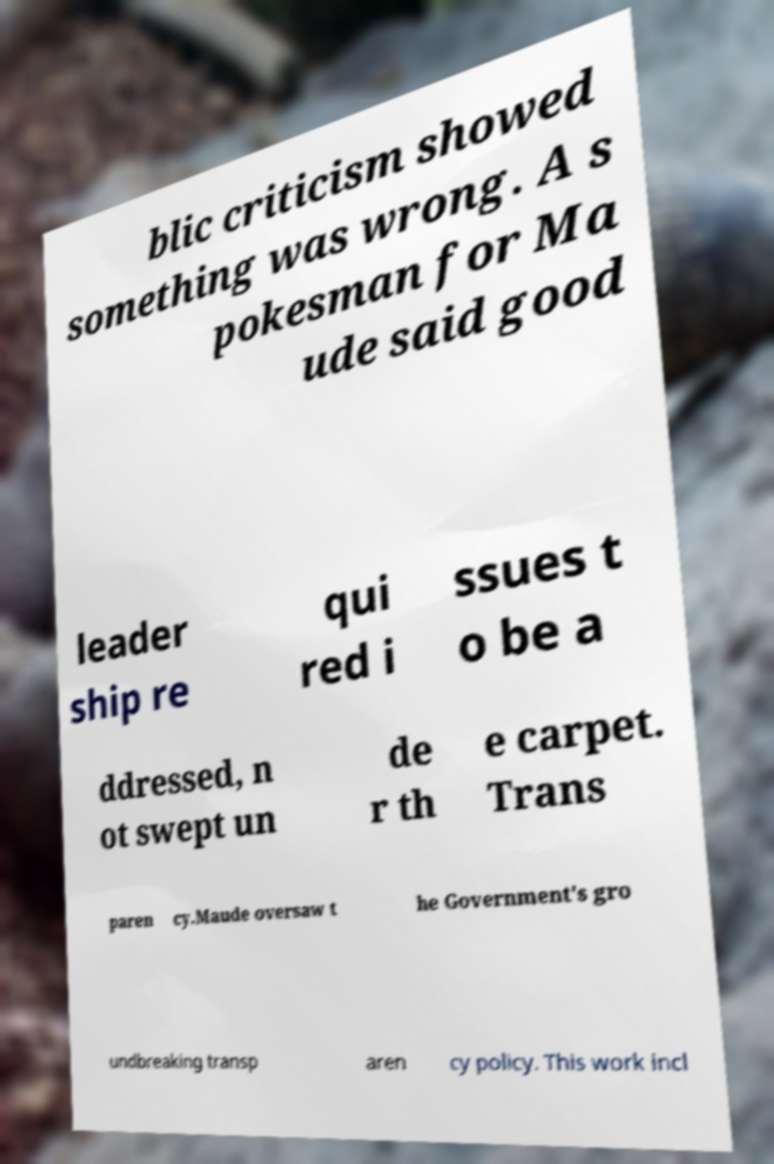Please read and relay the text visible in this image. What does it say? blic criticism showed something was wrong. A s pokesman for Ma ude said good leader ship re qui red i ssues t o be a ddressed, n ot swept un de r th e carpet. Trans paren cy.Maude oversaw t he Government's gro undbreaking transp aren cy policy. This work incl 